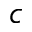Convert formula to latex. <formula><loc_0><loc_0><loc_500><loc_500>^ { c }</formula> 